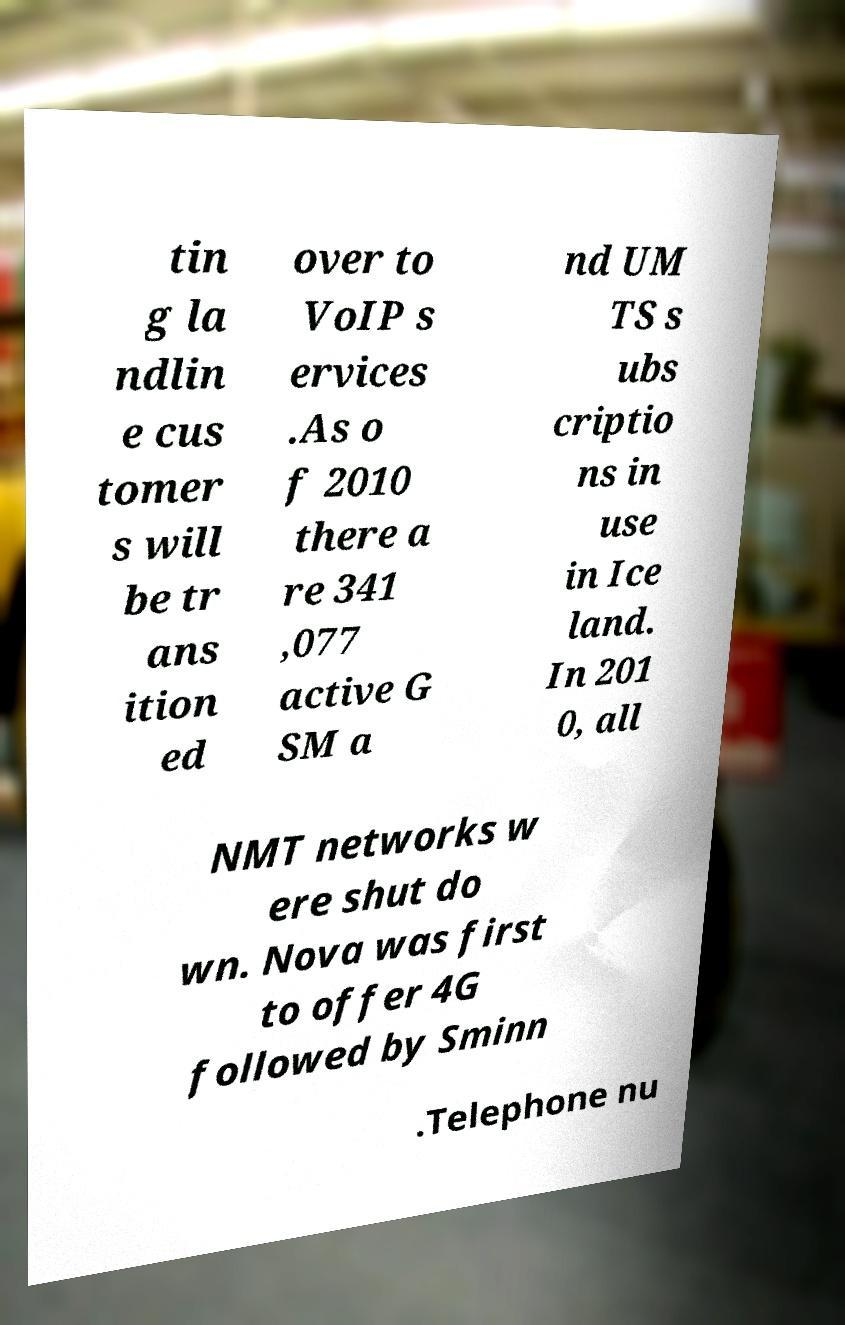Please read and relay the text visible in this image. What does it say? tin g la ndlin e cus tomer s will be tr ans ition ed over to VoIP s ervices .As o f 2010 there a re 341 ,077 active G SM a nd UM TS s ubs criptio ns in use in Ice land. In 201 0, all NMT networks w ere shut do wn. Nova was first to offer 4G followed by Sminn .Telephone nu 